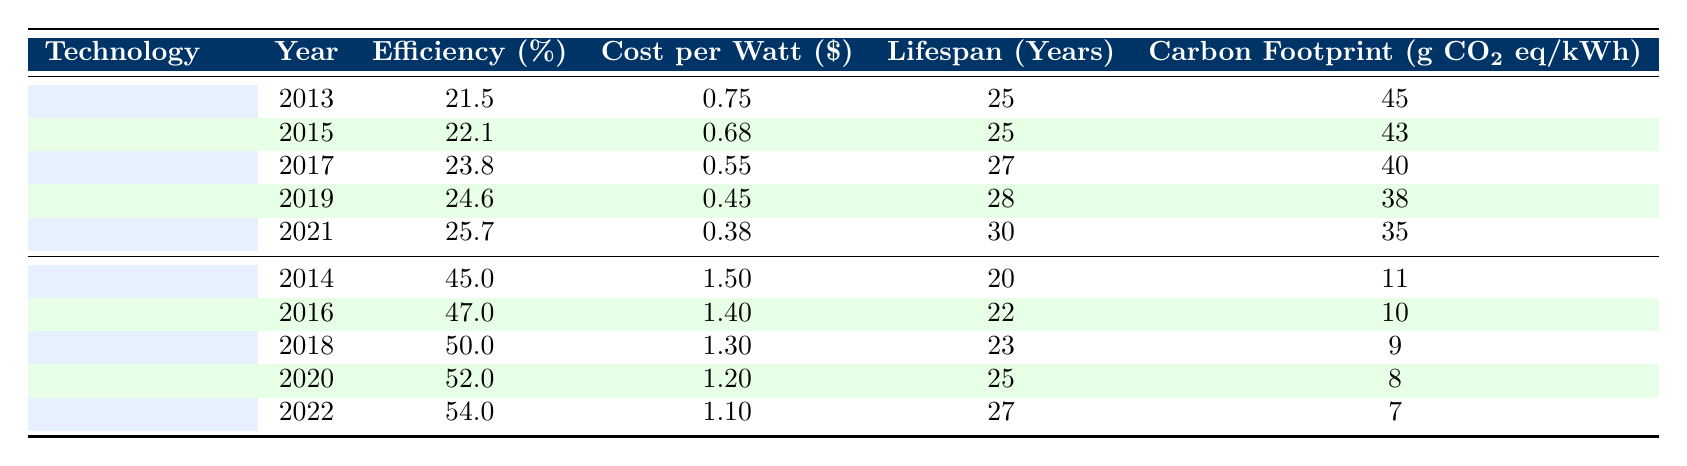What is the efficiency of Solar PV technology in 2019? The table shows that in 2019, the efficiency of Solar PV technology was 24.6%.
Answer: 24.6% What was the average carbon footprint of Wind Turbines from 2014 to 2022? The carbon footprints are 11, 10, 9, 8, and 7 g CO2 eq/kWh for the years 2014, 2016, 2018, 2020, and 2022 respectively. Adding them up gives 45, and dividing by 5 results in an average of 9.
Answer: 9 Is the cost per watt of Solar PV in 2021 lower than the cost per watt of Wind Turbines in 2022? The cost per watt for Solar PV in 2021 is 0.38, while for Wind Turbines in 2022, it is 1.10. Since 0.38 is less than 1.10, the statement is true.
Answer: Yes Which technology had a greater efficiency improvement from 2013 to 2022? Solar PV improved from 21.5% in 2013 to 25.7% in 2021, a difference of 4.2%. Wind Turbines improved from 45% in 2014 to 54% in 2022, a difference of 9%. Thus, Wind Turbines had a greater improvement.
Answer: Wind Turbines What is the cost per watt difference between the best-performing Solar PV and Wind Turbine technologies? The best-performing Solar PV in 2021 has a cost per watt of 0.38, while Wind Turbines in 2022 have a cost of 1.10. The difference is calculated as 1.10 - 0.38 = 0.72.
Answer: 0.72 Was the efficiency of Wind Turbines in 2018 higher than the efficiency of Solar PV in 2017? The efficiency of Wind Turbines in 2018 is 50%, while for Solar PV in 2017 it is 23.8%. Comparing the two shows that 50% is greater than 23.8%. Therefore, the statement is true.
Answer: Yes 